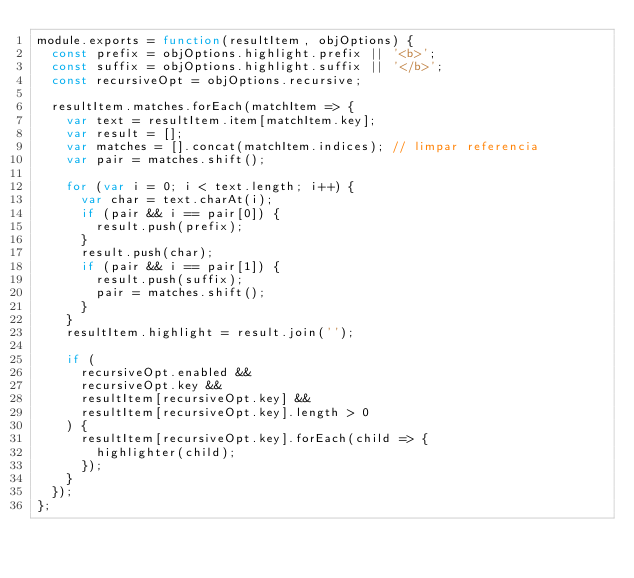Convert code to text. <code><loc_0><loc_0><loc_500><loc_500><_JavaScript_>module.exports = function(resultItem, objOptions) {
  const prefix = objOptions.highlight.prefix || '<b>';
  const suffix = objOptions.highlight.suffix || '</b>';
  const recursiveOpt = objOptions.recursive;

  resultItem.matches.forEach(matchItem => {
    var text = resultItem.item[matchItem.key];
    var result = [];
    var matches = [].concat(matchItem.indices); // limpar referencia
    var pair = matches.shift();

    for (var i = 0; i < text.length; i++) {
      var char = text.charAt(i);
      if (pair && i == pair[0]) {
        result.push(prefix);
      }
      result.push(char);
      if (pair && i == pair[1]) {
        result.push(suffix);
        pair = matches.shift();
      }
    }
    resultItem.highlight = result.join('');

    if (
      recursiveOpt.enabled &&
      recursiveOpt.key &&
      resultItem[recursiveOpt.key] &&
      resultItem[recursiveOpt.key].length > 0
    ) {
      resultItem[recursiveOpt.key].forEach(child => {
        highlighter(child);
      });
    }
  });
};
</code> 